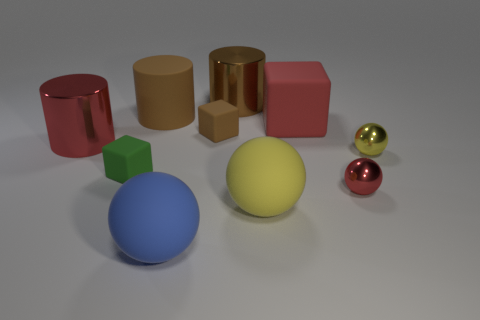How many red objects are left of the large yellow rubber ball and to the right of the large block?
Make the answer very short. 0. How many yellow objects have the same material as the blue sphere?
Give a very brief answer. 1. What size is the yellow sphere that is behind the yellow object that is in front of the tiny red shiny thing?
Give a very brief answer. Small. Is there a yellow rubber thing that has the same shape as the large blue matte object?
Ensure brevity in your answer.  Yes. There is a yellow thing behind the tiny green matte thing; does it have the same size as the red object to the right of the big red block?
Ensure brevity in your answer.  Yes. Are there fewer metallic cylinders in front of the matte cylinder than tiny objects that are to the right of the large yellow sphere?
Make the answer very short. Yes. What material is the tiny object that is the same color as the big rubber cylinder?
Give a very brief answer. Rubber. The small metallic sphere that is on the right side of the red metallic sphere is what color?
Offer a terse response. Yellow. There is a large metallic object in front of the red block that is behind the large blue object; how many big yellow spheres are behind it?
Your response must be concise. 0. The brown metal thing is what size?
Keep it short and to the point. Large. 